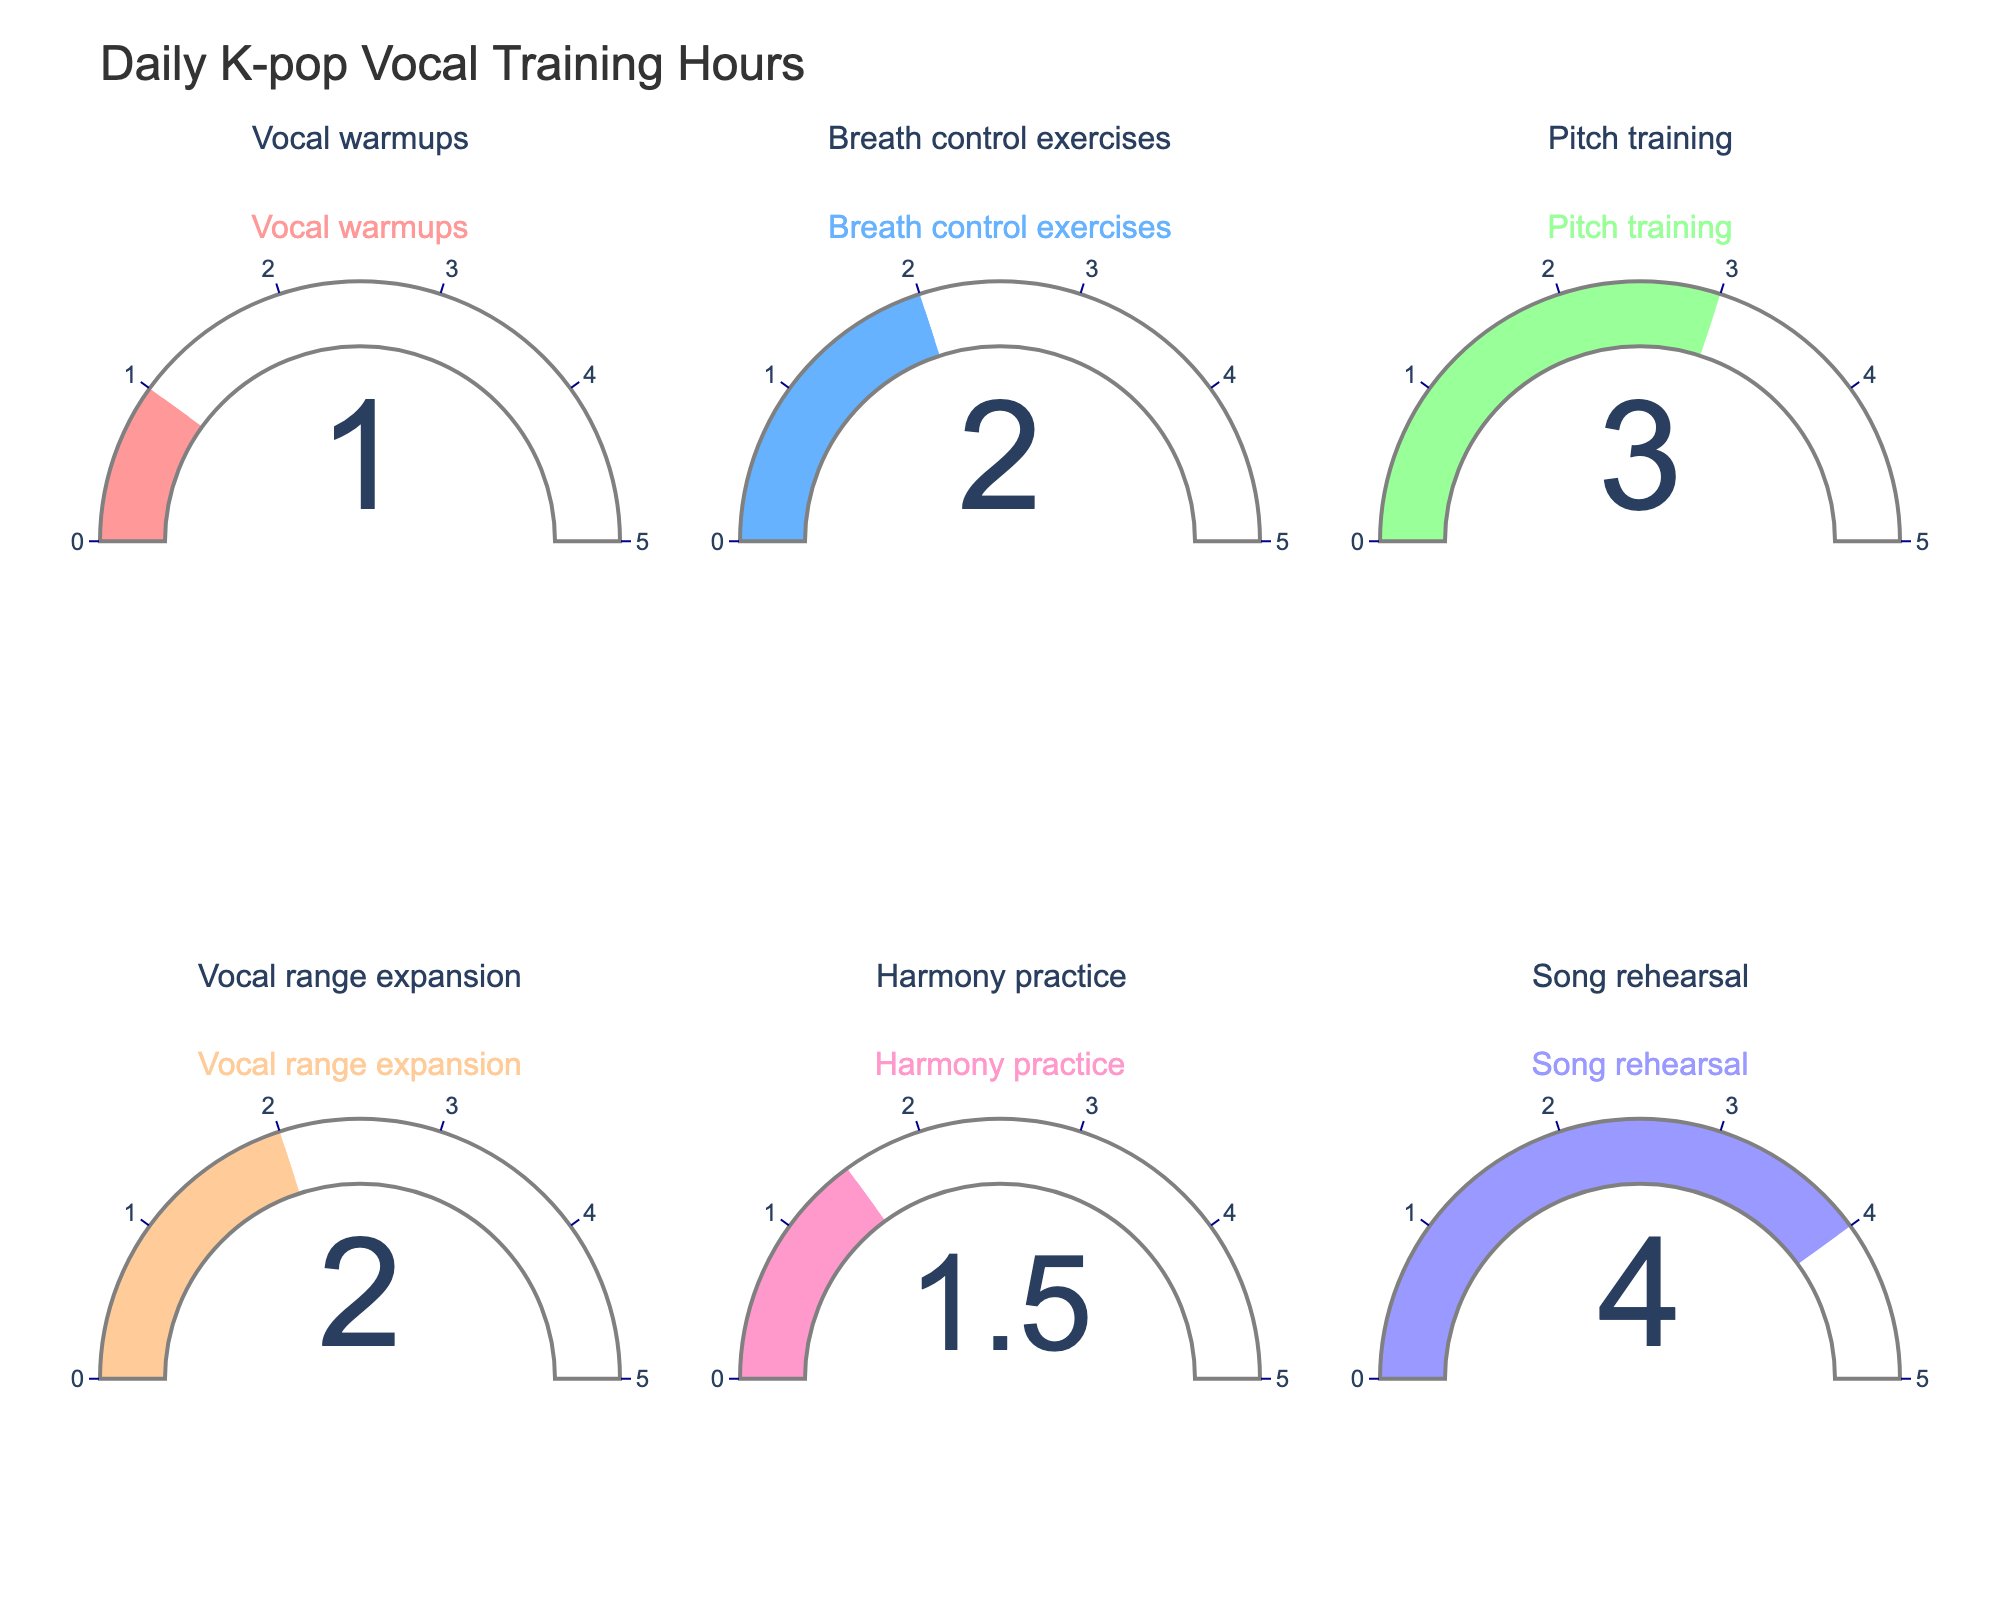what is the total number of hours spent on song rehearsal? Look at the gauge labeled "Song rehearsal" which shows the number "4". This represents the hours spent on song rehearsal.
Answer: 4 How many practice sessions are there in total? Count the number of gauges shown in the figure. Each gauge represents a different practice type.
Answer: 6 Which practice type has the least number of hours? Compare the values shown on each gauge. The practice type with the smallest number is "Vocal warmups" with "1" hour.
Answer: Vocal warmups What is the difference in hours between Song rehearsal and Harmony practice? Subtract the hours of Harmony practice (1.5) from Song rehearsal (4). 4 - 1.5 = 2.5.
Answer: 2.5 What is the average number of hours of all practice types? Sum up the hours for each practice type (1 + 2 + 3 + 2 + 1.5 + 4 = 13.5) and divide by the total number of practice types (6). 13.5 / 6 = 2.25.
Answer: 2.25 Which practice type has exactly 2 hours? Look at the gauges labeled with the practice types "Breath control exercises" and "Vocal range expansion". Both display the number "2".
Answer: Breath control exercises and Vocal range expansion How many practice types have more than 2 hours? Count the gauges showing values greater than 2. These are "Pitch training" with 3 hours and "Song rehearsal" with 4 hours.
Answer: 2 Is the total time spent on harmony practice more or less than the total time spent on vocal warmups? Compare the values of "Harmony practice" (1.5) and "Vocal warmups" (1). Harmony practice (1.5) is more than Vocal warmups (1).
Answer: More What is the overall title of the figure? Look at the title displayed at the top of the figure reading “Daily K-pop Vocal Training Hours”.
Answer: Daily K-pop Vocal Training Hours 